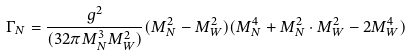Convert formula to latex. <formula><loc_0><loc_0><loc_500><loc_500>\Gamma _ { N } = \frac { g ^ { 2 } } { ( 3 2 \pi M _ { N } ^ { 3 } M _ { W } ^ { 2 } ) } ( M _ { N } ^ { 2 } - M _ { W } ^ { 2 } ) ( M _ { N } ^ { 4 } + M _ { N } ^ { 2 } \cdot M _ { W } ^ { 2 } - 2 M _ { W } ^ { 4 } )</formula> 